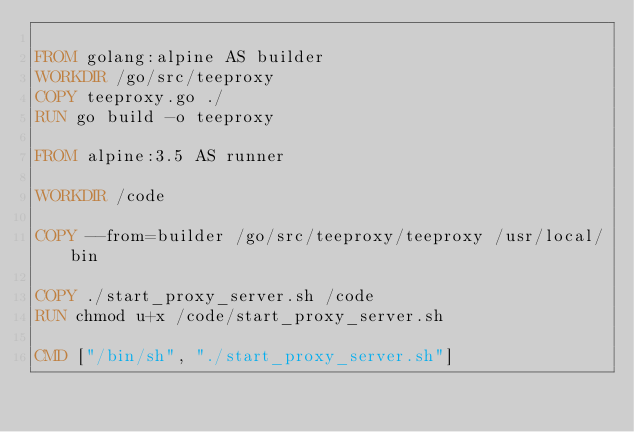<code> <loc_0><loc_0><loc_500><loc_500><_Dockerfile_>
FROM golang:alpine AS builder
WORKDIR /go/src/teeproxy
COPY teeproxy.go ./
RUN go build -o teeproxy

FROM alpine:3.5 AS runner

WORKDIR /code

COPY --from=builder /go/src/teeproxy/teeproxy /usr/local/bin

COPY ./start_proxy_server.sh /code
RUN chmod u+x /code/start_proxy_server.sh

CMD ["/bin/sh", "./start_proxy_server.sh"]
</code> 